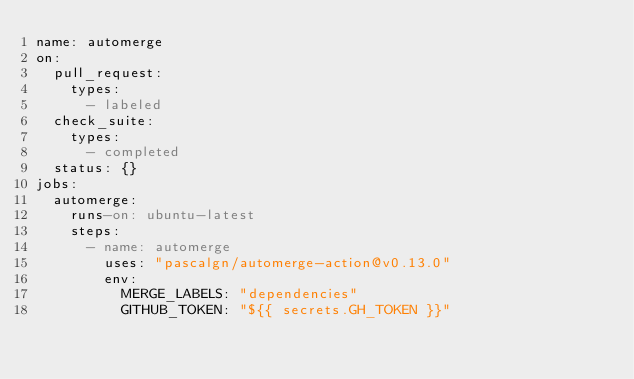<code> <loc_0><loc_0><loc_500><loc_500><_YAML_>name: automerge
on:
  pull_request:
    types:
      - labeled
  check_suite:
    types:
      - completed
  status: {}
jobs:
  automerge:
    runs-on: ubuntu-latest
    steps:
      - name: automerge
        uses: "pascalgn/automerge-action@v0.13.0"
        env:
          MERGE_LABELS: "dependencies"
          GITHUB_TOKEN: "${{ secrets.GH_TOKEN }}"</code> 